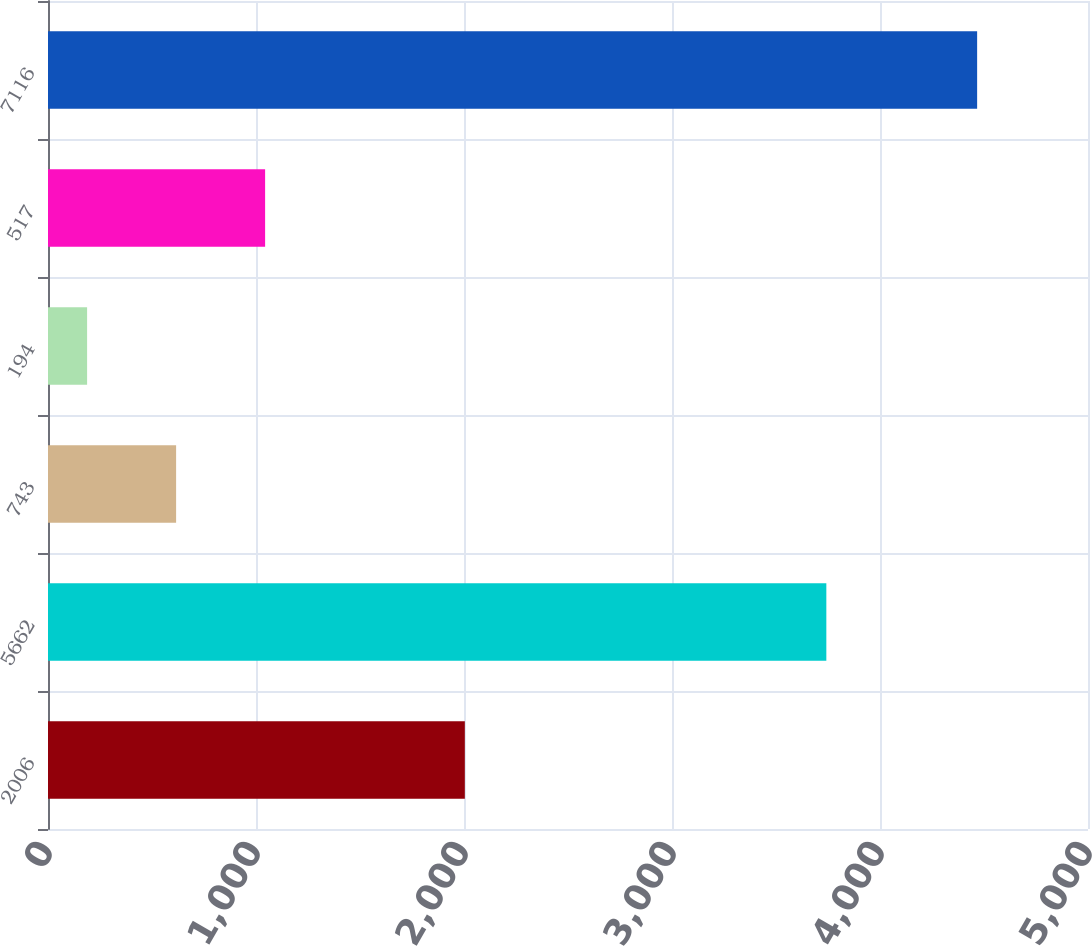Convert chart. <chart><loc_0><loc_0><loc_500><loc_500><bar_chart><fcel>2006<fcel>5662<fcel>743<fcel>194<fcel>517<fcel>7116<nl><fcel>2004<fcel>3742<fcel>615.9<fcel>188<fcel>1043.8<fcel>4467<nl></chart> 